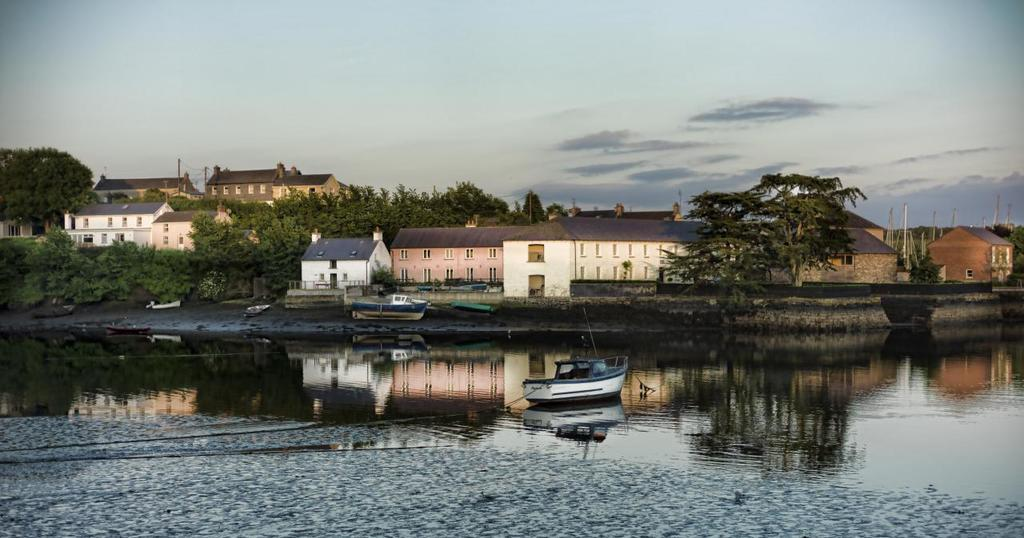What can be seen in the background of the image? In the background of the image, there is sky, buildings, and trees visible. What is present in the foreground of the image? There is water visible in the image, and boats are in the water. How many elements can be identified in the background of the image? There are three elements in the background of the image: sky, buildings, and trees. How does the garden move in the image? There is no garden present in the image. 